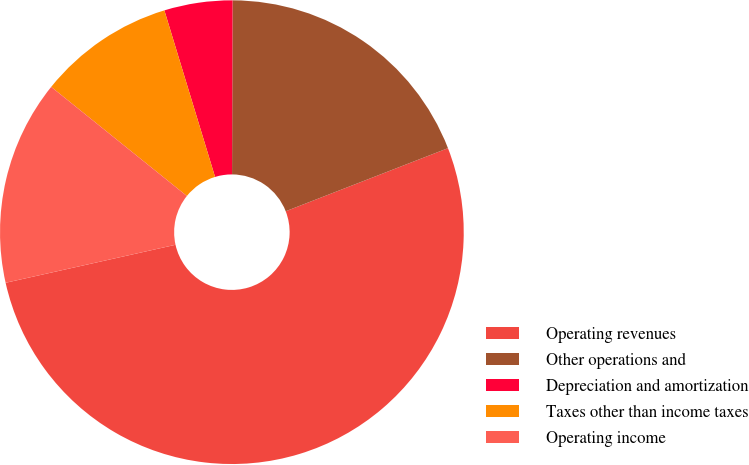Convert chart. <chart><loc_0><loc_0><loc_500><loc_500><pie_chart><fcel>Operating revenues<fcel>Other operations and<fcel>Depreciation and amortization<fcel>Taxes other than income taxes<fcel>Operating income<nl><fcel>52.4%<fcel>19.05%<fcel>4.75%<fcel>9.52%<fcel>14.28%<nl></chart> 